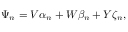Convert formula to latex. <formula><loc_0><loc_0><loc_500><loc_500>\Psi _ { n } = V \alpha _ { n } + W \beta _ { n } + Y \zeta _ { n } ,</formula> 